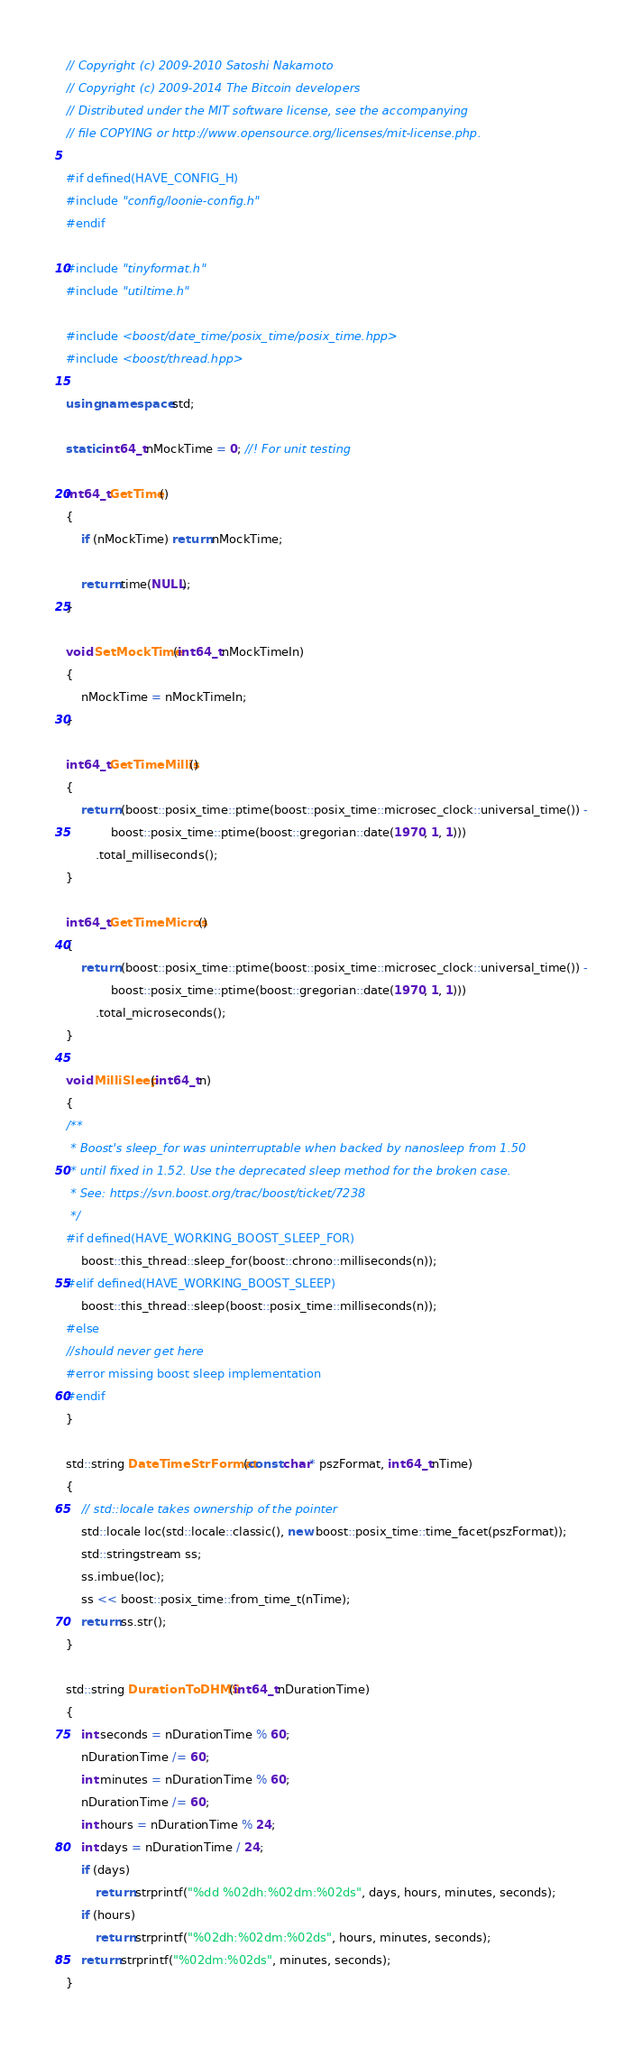Convert code to text. <code><loc_0><loc_0><loc_500><loc_500><_C++_>// Copyright (c) 2009-2010 Satoshi Nakamoto
// Copyright (c) 2009-2014 The Bitcoin developers
// Distributed under the MIT software license, see the accompanying
// file COPYING or http://www.opensource.org/licenses/mit-license.php.

#if defined(HAVE_CONFIG_H)
#include "config/loonie-config.h"
#endif

#include "tinyformat.h"
#include "utiltime.h"

#include <boost/date_time/posix_time/posix_time.hpp>
#include <boost/thread.hpp>

using namespace std;

static int64_t nMockTime = 0; //! For unit testing

int64_t GetTime()
{
    if (nMockTime) return nMockTime;

    return time(NULL);
}

void SetMockTime(int64_t nMockTimeIn)
{
    nMockTime = nMockTimeIn;
}

int64_t GetTimeMillis()
{
    return (boost::posix_time::ptime(boost::posix_time::microsec_clock::universal_time()) -
            boost::posix_time::ptime(boost::gregorian::date(1970, 1, 1)))
        .total_milliseconds();
}

int64_t GetTimeMicros()
{
    return (boost::posix_time::ptime(boost::posix_time::microsec_clock::universal_time()) -
            boost::posix_time::ptime(boost::gregorian::date(1970, 1, 1)))
        .total_microseconds();
}

void MilliSleep(int64_t n)
{
/**
 * Boost's sleep_for was uninterruptable when backed by nanosleep from 1.50
 * until fixed in 1.52. Use the deprecated sleep method for the broken case.
 * See: https://svn.boost.org/trac/boost/ticket/7238
 */
#if defined(HAVE_WORKING_BOOST_SLEEP_FOR)
    boost::this_thread::sleep_for(boost::chrono::milliseconds(n));
#elif defined(HAVE_WORKING_BOOST_SLEEP)
    boost::this_thread::sleep(boost::posix_time::milliseconds(n));
#else
//should never get here
#error missing boost sleep implementation
#endif
}

std::string DateTimeStrFormat(const char* pszFormat, int64_t nTime)
{
    // std::locale takes ownership of the pointer
    std::locale loc(std::locale::classic(), new boost::posix_time::time_facet(pszFormat));
    std::stringstream ss;
    ss.imbue(loc);
    ss << boost::posix_time::from_time_t(nTime);
    return ss.str();
}

std::string DurationToDHMS(int64_t nDurationTime)
{
    int seconds = nDurationTime % 60;
    nDurationTime /= 60;
    int minutes = nDurationTime % 60;
    nDurationTime /= 60;
    int hours = nDurationTime % 24;
    int days = nDurationTime / 24;
    if (days)
        return strprintf("%dd %02dh:%02dm:%02ds", days, hours, minutes, seconds);
    if (hours)
        return strprintf("%02dh:%02dm:%02ds", hours, minutes, seconds);
    return strprintf("%02dm:%02ds", minutes, seconds);
}
</code> 